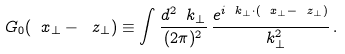<formula> <loc_0><loc_0><loc_500><loc_500>G _ { 0 } ( \ x _ { \perp } - \ z _ { \perp } ) \equiv \int \frac { d ^ { 2 } \ k _ { \perp } } { ( 2 \pi ) ^ { 2 } } \, \frac { e ^ { i \ k _ { \perp } \cdot ( \ x _ { \perp } - \ z _ { \perp } ) } } { \ k _ { \perp } ^ { 2 } } \, .</formula> 